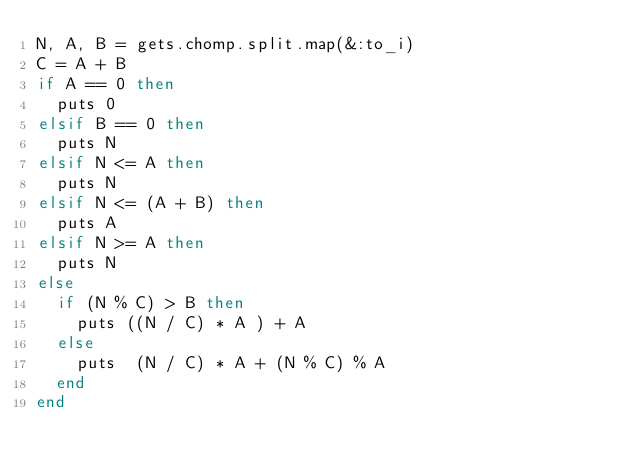<code> <loc_0><loc_0><loc_500><loc_500><_Ruby_>N, A, B = gets.chomp.split.map(&:to_i)
C = A + B
if A == 0 then
  puts 0
elsif B == 0 then
  puts N
elsif N <= A then
  puts N
elsif N <= (A + B) then
  puts A
elsif N >= A then
  puts N
else
  if (N % C) > B then
    puts ((N / C) * A ) + A
  else
    puts  (N / C) * A + (N % C) % A
  end
end</code> 